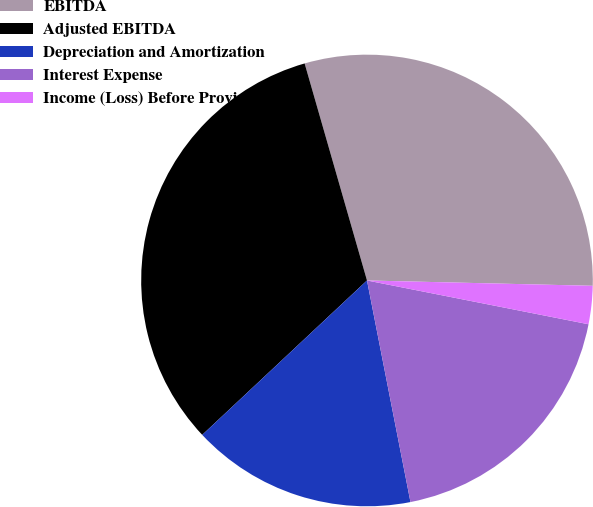<chart> <loc_0><loc_0><loc_500><loc_500><pie_chart><fcel>EBITDA<fcel>Adjusted EBITDA<fcel>Depreciation and Amortization<fcel>Interest Expense<fcel>Income (Loss) Before Provision<nl><fcel>29.83%<fcel>32.53%<fcel>16.1%<fcel>18.81%<fcel>2.73%<nl></chart> 